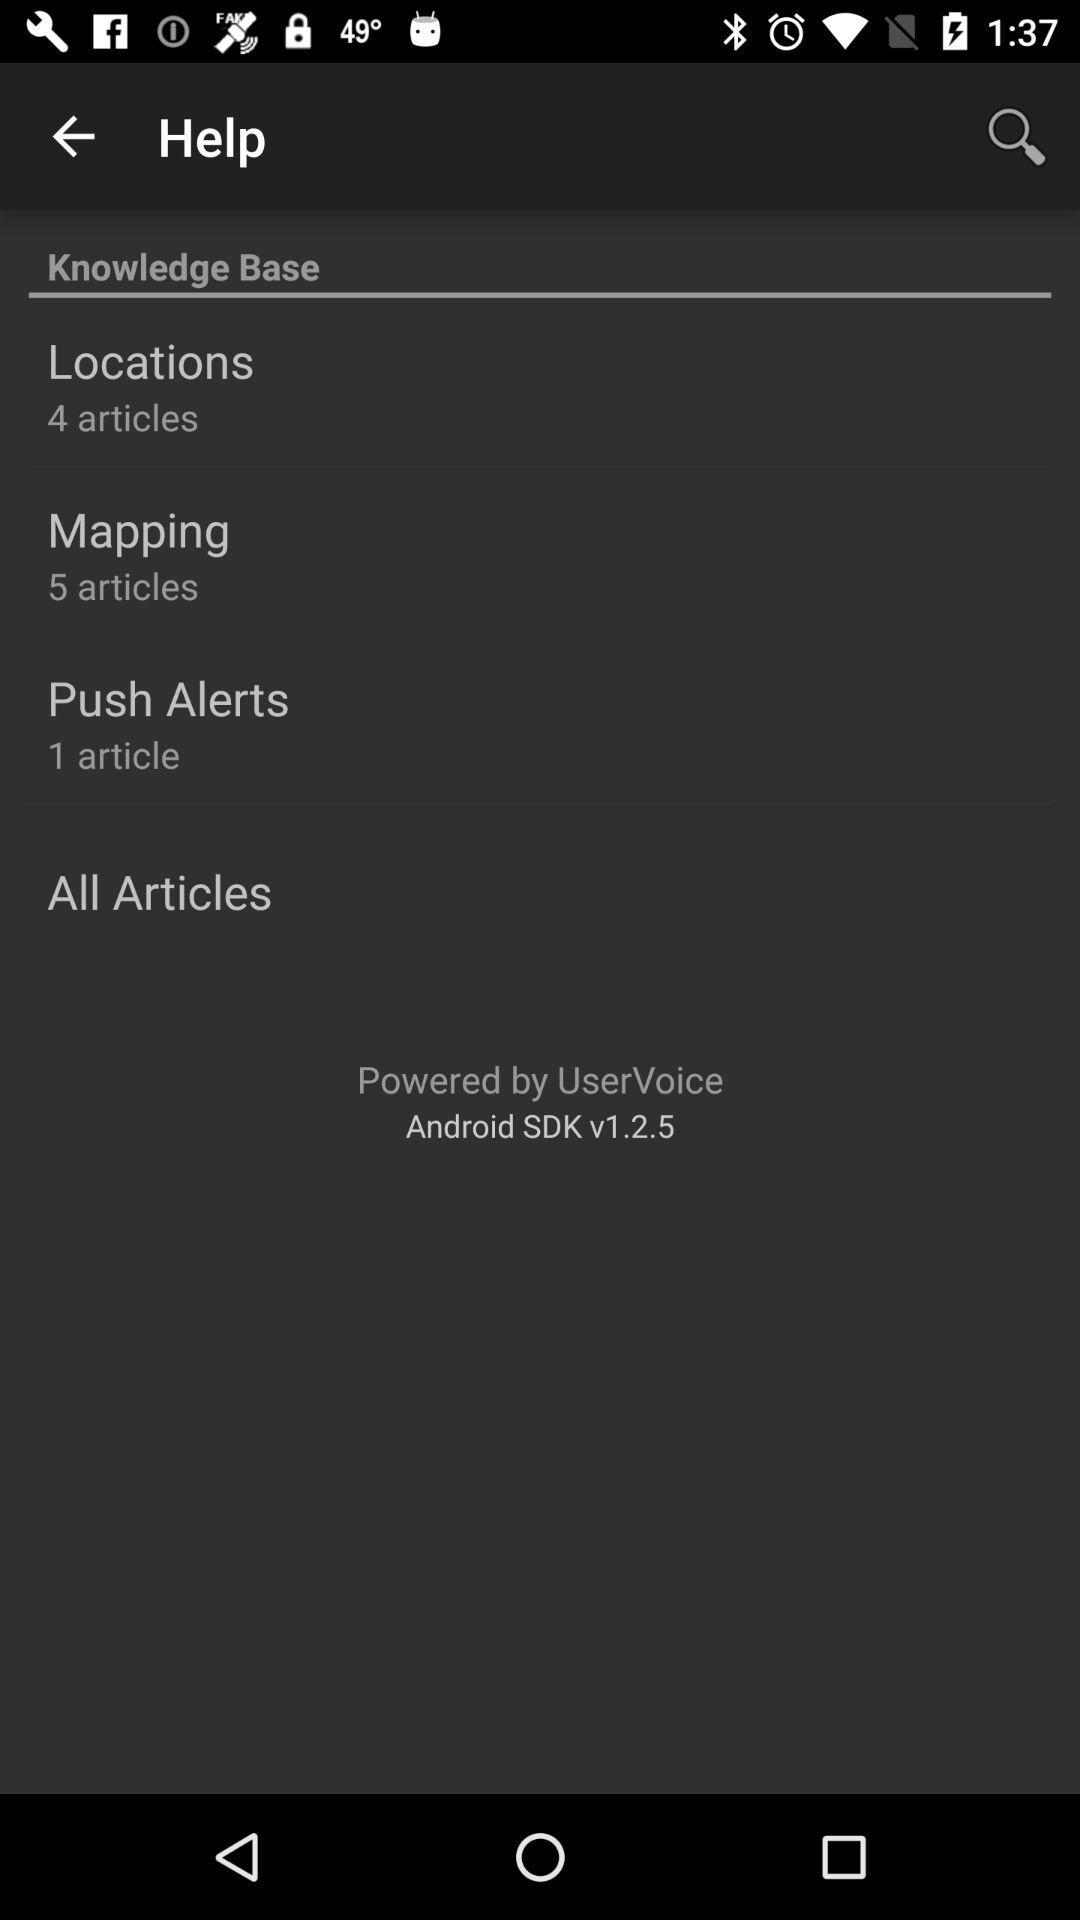What is the version of the Android SDK? The version of the Android SDK is 1.2.5. 